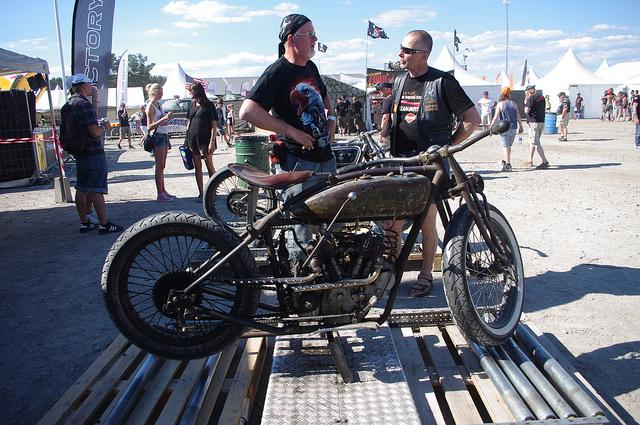What material are the pipes which are holding up the old bike? Please explain your reasoning. wood. They are flat slats. 